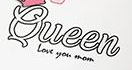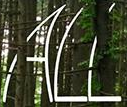What text is displayed in these images sequentially, separated by a semicolon? Queen; ALL 